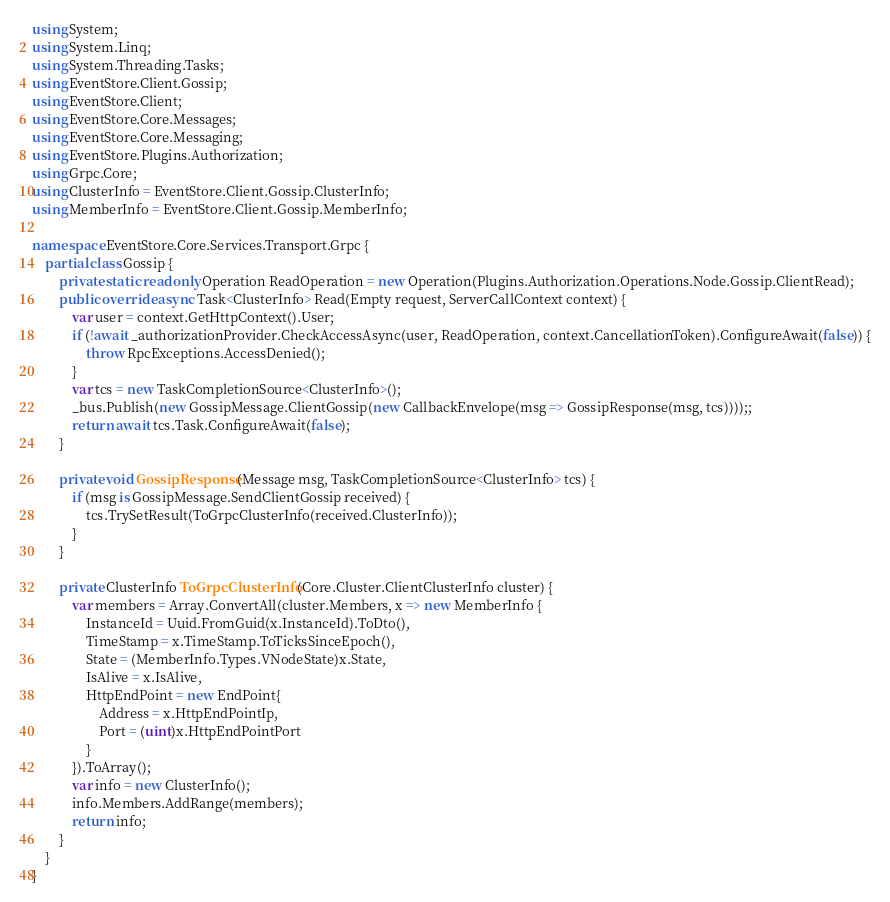<code> <loc_0><loc_0><loc_500><loc_500><_C#_>using System;
using System.Linq;
using System.Threading.Tasks;
using EventStore.Client.Gossip;
using EventStore.Client;
using EventStore.Core.Messages;
using EventStore.Core.Messaging;
using EventStore.Plugins.Authorization;
using Grpc.Core;
using ClusterInfo = EventStore.Client.Gossip.ClusterInfo;
using MemberInfo = EventStore.Client.Gossip.MemberInfo;

namespace EventStore.Core.Services.Transport.Grpc {
	partial class Gossip {
		private static readonly Operation ReadOperation = new Operation(Plugins.Authorization.Operations.Node.Gossip.ClientRead);
		public override async Task<ClusterInfo> Read(Empty request, ServerCallContext context) {
			var user = context.GetHttpContext().User;
			if (!await _authorizationProvider.CheckAccessAsync(user, ReadOperation, context.CancellationToken).ConfigureAwait(false)) {
				throw RpcExceptions.AccessDenied();
			}
			var tcs = new TaskCompletionSource<ClusterInfo>();
			_bus.Publish(new GossipMessage.ClientGossip(new CallbackEnvelope(msg => GossipResponse(msg, tcs))));;
			return await tcs.Task.ConfigureAwait(false);
		}

		private void GossipResponse(Message msg, TaskCompletionSource<ClusterInfo> tcs) {
			if (msg is GossipMessage.SendClientGossip received) {
				tcs.TrySetResult(ToGrpcClusterInfo(received.ClusterInfo));
			}
		}

		private ClusterInfo ToGrpcClusterInfo(Core.Cluster.ClientClusterInfo cluster) {
			var members = Array.ConvertAll(cluster.Members, x => new MemberInfo {
				InstanceId = Uuid.FromGuid(x.InstanceId).ToDto(),
				TimeStamp = x.TimeStamp.ToTicksSinceEpoch(),
				State = (MemberInfo.Types.VNodeState)x.State,
				IsAlive = x.IsAlive,
				HttpEndPoint = new EndPoint{
					Address = x.HttpEndPointIp,
					Port = (uint)x.HttpEndPointPort
				}
			}).ToArray();
			var info = new ClusterInfo();
			info.Members.AddRange(members);
			return info;
		}
	}
}
</code> 